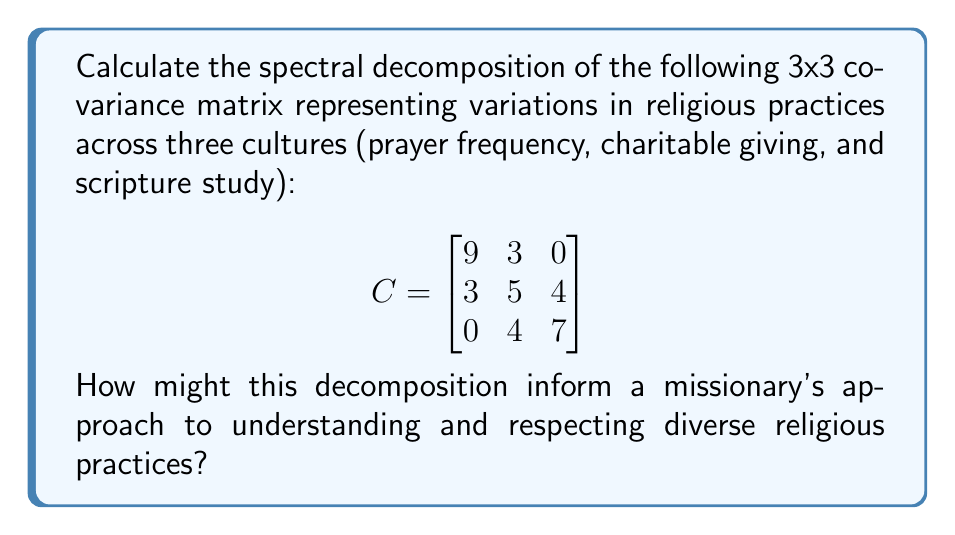Can you answer this question? To calculate the spectral decomposition of the covariance matrix C, we need to find its eigenvalues and eigenvectors. The spectral decomposition is given by $C = P\Lambda P^{-1}$, where P is the matrix of eigenvectors and Λ is the diagonal matrix of eigenvalues.

Step 1: Find the eigenvalues by solving the characteristic equation:
$\det(C - \lambda I) = 0$

$$\begin{vmatrix}
9-\lambda & 3 & 0 \\
3 & 5-\lambda & 4 \\
0 & 4 & 7-\lambda
\end{vmatrix} = 0$$

$(9-\lambda)[(5-\lambda)(7-\lambda)-16] - 3[3(7-\lambda)] = 0$

Simplifying: $-\lambda^3 + 21\lambda^2 - 134\lambda + 225 = 0$

The roots of this equation are the eigenvalues: $\lambda_1 = 15$, $\lambda_2 = 5$, $\lambda_3 = 1$

Step 2: Find the eigenvectors for each eigenvalue by solving $(C - \lambda I)v = 0$

For $\lambda_1 = 15$:
$$\begin{bmatrix}
-6 & 3 & 0 \\
3 & -10 & 4 \\
0 & 4 & -8
\end{bmatrix}\begin{bmatrix}
v_1 \\ v_2 \\ v_3
\end{bmatrix} = \begin{bmatrix}
0 \\ 0 \\ 0
\end{bmatrix}$$

Solving this system gives the eigenvector: $v_1 = (2, 1, 1)^T$

Similarly, for $\lambda_2 = 5$ and $\lambda_3 = 1$, we get:
$v_2 = (-1, 1, 1)^T$ and $v_3 = (0, -1, 1)^T$

Step 3: Normalize the eigenvectors and form the matrix P:

$$P = \begin{bmatrix}
\frac{2}{\sqrt{6}} & -\frac{1}{\sqrt{3}} & 0 \\
\frac{1}{\sqrt{6}} & \frac{1}{\sqrt{3}} & -\frac{1}{\sqrt{2}} \\
\frac{1}{\sqrt{6}} & \frac{1}{\sqrt{3}} & \frac{1}{\sqrt{2}}
\end{bmatrix}$$

Step 4: Form the diagonal matrix Λ of eigenvalues:

$$\Lambda = \begin{bmatrix}
15 & 0 & 0 \\
0 & 5 & 0 \\
0 & 0 & 1
\end{bmatrix}$$

The spectral decomposition is thus $C = P\Lambda P^{-1}$

This decomposition can inform a missionary's approach by revealing the main axes of variation in religious practices across cultures. The largest eigenvalue (15) corresponds to the direction of greatest variation, which could represent overall religious devotion. The other eigenvalues represent secondary and tertiary axes of variation, potentially highlighting specific differences in practices. Understanding these patterns can help a missionary adapt their approach to respect and engage with diverse religious expressions.
Answer: $C = P\Lambda P^{-1}$, where $P = \begin{bmatrix}
\frac{2}{\sqrt{6}} & -\frac{1}{\sqrt{3}} & 0 \\
\frac{1}{\sqrt{6}} & \frac{1}{\sqrt{3}} & -\frac{1}{\sqrt{2}} \\
\frac{1}{\sqrt{6}} & \frac{1}{\sqrt{3}} & \frac{1}{\sqrt{2}}
\end{bmatrix}$ and $\Lambda = \begin{bmatrix}
15 & 0 & 0 \\
0 & 5 & 0 \\
0 & 0 & 1
\end{bmatrix}$ 